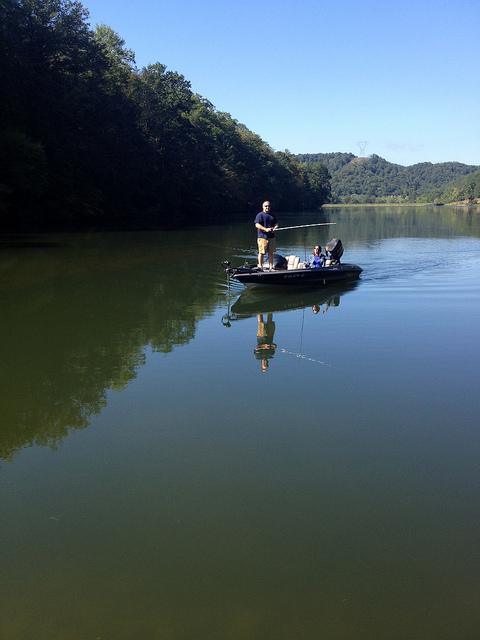How many boats are in the water?
Keep it brief. 1. Is it cold in this picture?
Quick response, please. No. Is the water clear?
Answer briefly. No. Are they fishing?
Concise answer only. Yes. What is the motion of the water?
Short answer required. Calm. Is the man fishing?
Give a very brief answer. Yes. Is the boat being used?
Give a very brief answer. Yes. What color is the boat?
Keep it brief. Black. Was this picture taken in a desert?
Write a very short answer. No. Are there ducks in the water?
Keep it brief. No. What are they doing on the water?
Concise answer only. Fishing. Are there any clouds in the sky?
Short answer required. No. Is the river moving?
Short answer required. No. How many people are in the boat?
Answer briefly. 2. How many people are in the water?
Quick response, please. 0. Is the man wearing a hat?
Concise answer only. No. Is this a cloudy day?
Write a very short answer. No. Is the water choppy?
Be succinct. No. Is it a sunny day?
Concise answer only. Yes. 